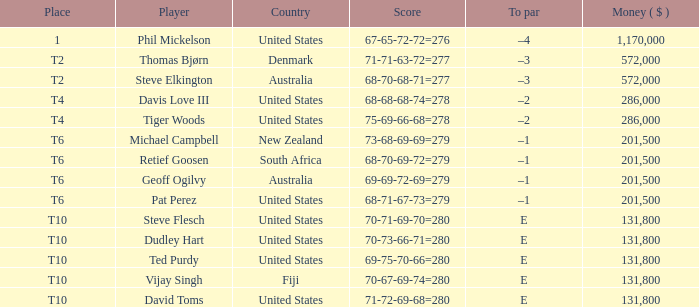Help me parse the entirety of this table. {'header': ['Place', 'Player', 'Country', 'Score', 'To par', 'Money ( $ )'], 'rows': [['1', 'Phil Mickelson', 'United States', '67-65-72-72=276', '–4', '1,170,000'], ['T2', 'Thomas Bjørn', 'Denmark', '71-71-63-72=277', '–3', '572,000'], ['T2', 'Steve Elkington', 'Australia', '68-70-68-71=277', '–3', '572,000'], ['T4', 'Davis Love III', 'United States', '68-68-68-74=278', '–2', '286,000'], ['T4', 'Tiger Woods', 'United States', '75-69-66-68=278', '–2', '286,000'], ['T6', 'Michael Campbell', 'New Zealand', '73-68-69-69=279', '–1', '201,500'], ['T6', 'Retief Goosen', 'South Africa', '68-70-69-72=279', '–1', '201,500'], ['T6', 'Geoff Ogilvy', 'Australia', '69-69-72-69=279', '–1', '201,500'], ['T6', 'Pat Perez', 'United States', '68-71-67-73=279', '–1', '201,500'], ['T10', 'Steve Flesch', 'United States', '70-71-69-70=280', 'E', '131,800'], ['T10', 'Dudley Hart', 'United States', '70-73-66-71=280', 'E', '131,800'], ['T10', 'Ted Purdy', 'United States', '69-75-70-66=280', 'E', '131,800'], ['T10', 'Vijay Singh', 'Fiji', '70-67-69-74=280', 'E', '131,800'], ['T10', 'David Toms', 'United States', '71-72-69-68=280', 'E', '131,800']]} What is the largest money for a t4 place, for Tiger Woods? 286000.0. 